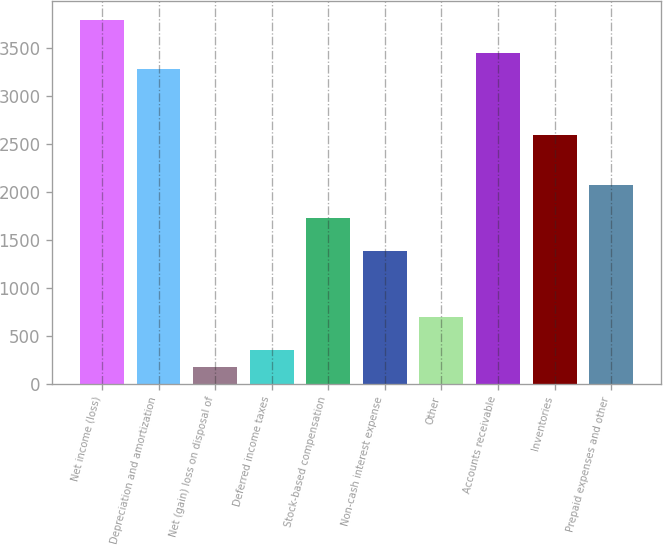Convert chart. <chart><loc_0><loc_0><loc_500><loc_500><bar_chart><fcel>Net income (loss)<fcel>Depreciation and amortization<fcel>Net (gain) loss on disposal of<fcel>Deferred income taxes<fcel>Stock-based compensation<fcel>Non-cash interest expense<fcel>Other<fcel>Accounts receivable<fcel>Inventories<fcel>Prepaid expenses and other<nl><fcel>3796<fcel>3278.5<fcel>173.5<fcel>346<fcel>1726<fcel>1381<fcel>691<fcel>3451<fcel>2588.5<fcel>2071<nl></chart> 